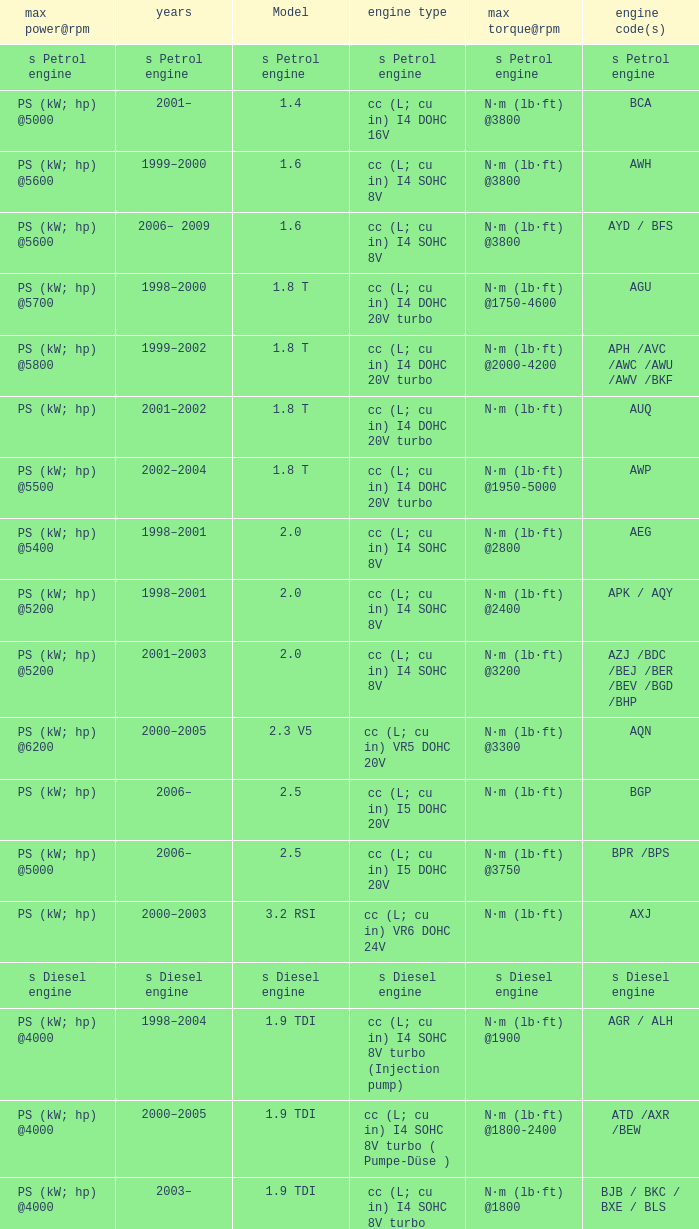5 model engine with a maximum power@rpm of ps (kw; hp) @5000? N·m (lb·ft) @3750. 